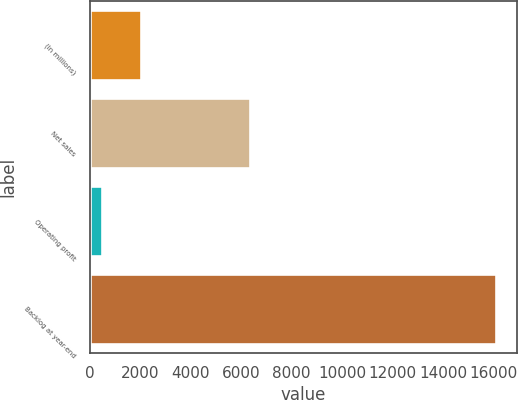Convert chart. <chart><loc_0><loc_0><loc_500><loc_500><bar_chart><fcel>(In millions)<fcel>Net sales<fcel>Operating profit<fcel>Backlog at year-end<nl><fcel>2051.3<fcel>6359<fcel>489<fcel>16112<nl></chart> 